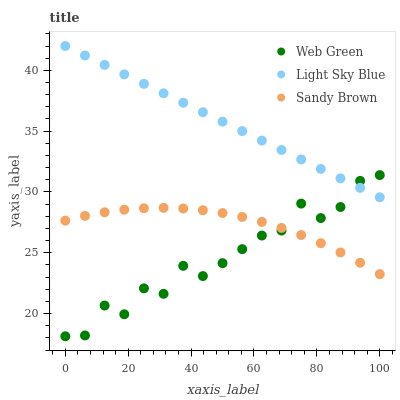Does Web Green have the minimum area under the curve?
Answer yes or no. Yes. Does Light Sky Blue have the maximum area under the curve?
Answer yes or no. Yes. Does Sandy Brown have the minimum area under the curve?
Answer yes or no. No. Does Sandy Brown have the maximum area under the curve?
Answer yes or no. No. Is Light Sky Blue the smoothest?
Answer yes or no. Yes. Is Web Green the roughest?
Answer yes or no. Yes. Is Sandy Brown the smoothest?
Answer yes or no. No. Is Sandy Brown the roughest?
Answer yes or no. No. Does Web Green have the lowest value?
Answer yes or no. Yes. Does Sandy Brown have the lowest value?
Answer yes or no. No. Does Light Sky Blue have the highest value?
Answer yes or no. Yes. Does Web Green have the highest value?
Answer yes or no. No. Is Sandy Brown less than Light Sky Blue?
Answer yes or no. Yes. Is Light Sky Blue greater than Sandy Brown?
Answer yes or no. Yes. Does Light Sky Blue intersect Web Green?
Answer yes or no. Yes. Is Light Sky Blue less than Web Green?
Answer yes or no. No. Is Light Sky Blue greater than Web Green?
Answer yes or no. No. Does Sandy Brown intersect Light Sky Blue?
Answer yes or no. No. 